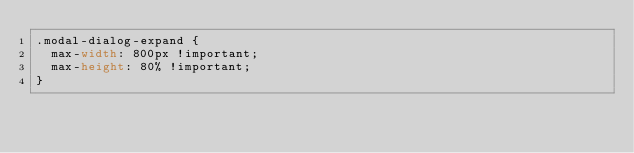<code> <loc_0><loc_0><loc_500><loc_500><_CSS_>.modal-dialog-expand {
  max-width: 800px !important;
  max-height: 80% !important;
}
</code> 